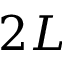Convert formula to latex. <formula><loc_0><loc_0><loc_500><loc_500>2 L</formula> 